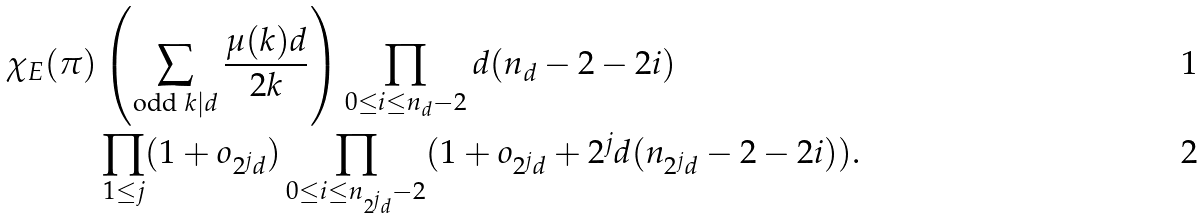Convert formula to latex. <formula><loc_0><loc_0><loc_500><loc_500>\chi _ { E } ( \pi ) & \left ( \sum _ { \text {odd } k | d } \frac { \mu ( k ) d } { 2 k } \right ) \prod _ { 0 \leq i \leq n _ { d } - 2 } d ( n _ { d } - 2 - 2 i ) \\ & \prod _ { 1 \leq j } ( 1 + o _ { 2 ^ { j } d } ) \prod _ { 0 \leq i \leq n _ { 2 ^ { j } d } - 2 } ( 1 + o _ { 2 ^ { j } d } + 2 ^ { j } d ( n _ { 2 ^ { j } d } - 2 - 2 i ) ) .</formula> 